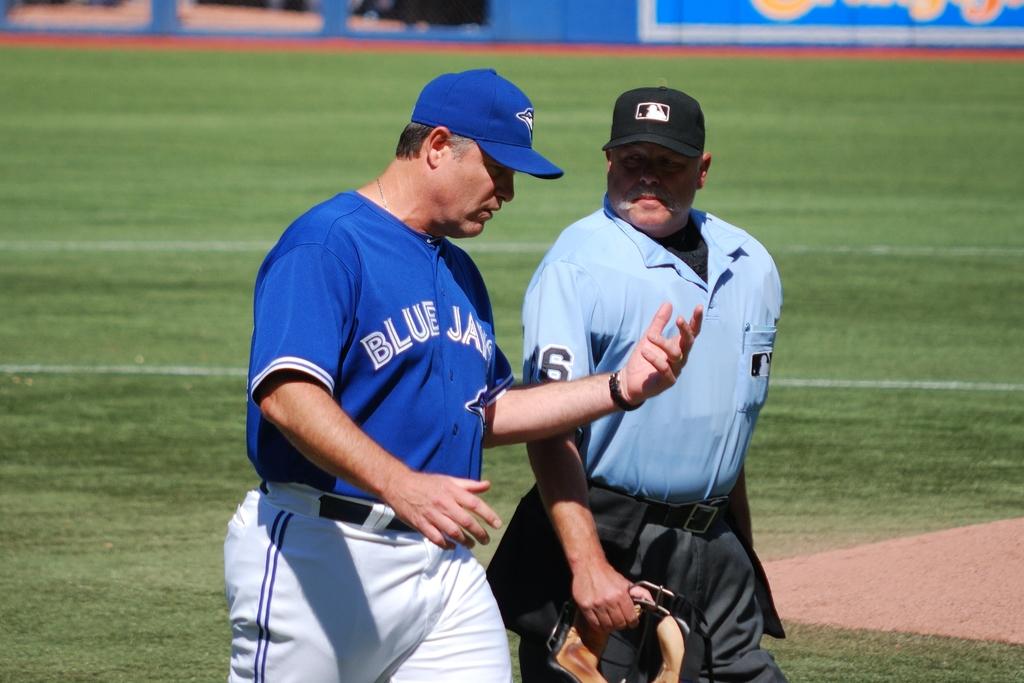What number is the ref wearing?
Give a very brief answer. 6. 